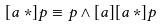Convert formula to latex. <formula><loc_0><loc_0><loc_500><loc_500>[ a * ] p \equiv p \wedge [ a ] [ a * ] p</formula> 